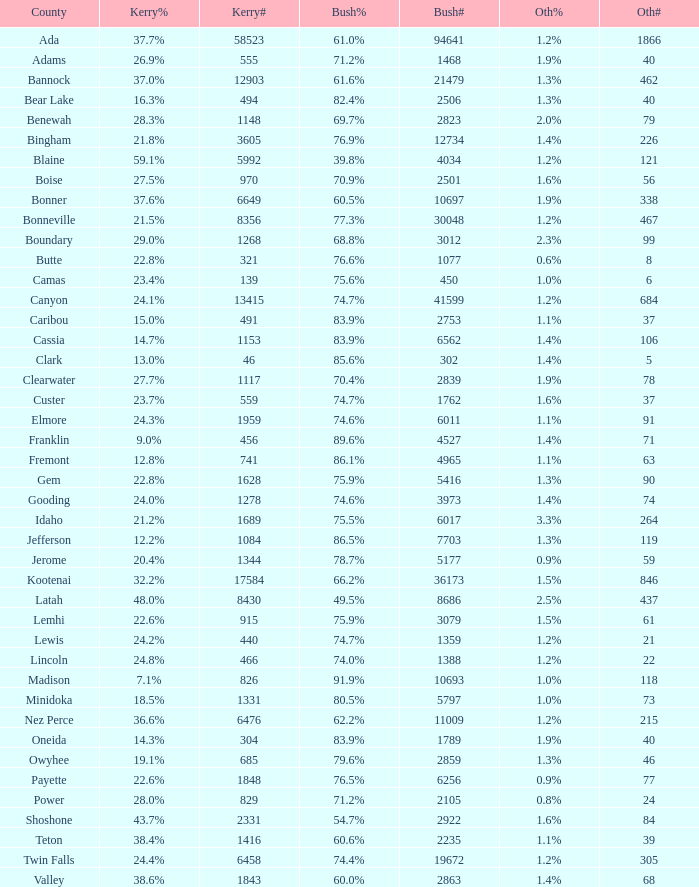How many different counts of the votes for Bush are there in the county where he got 69.7% of the votes? 1.0. 